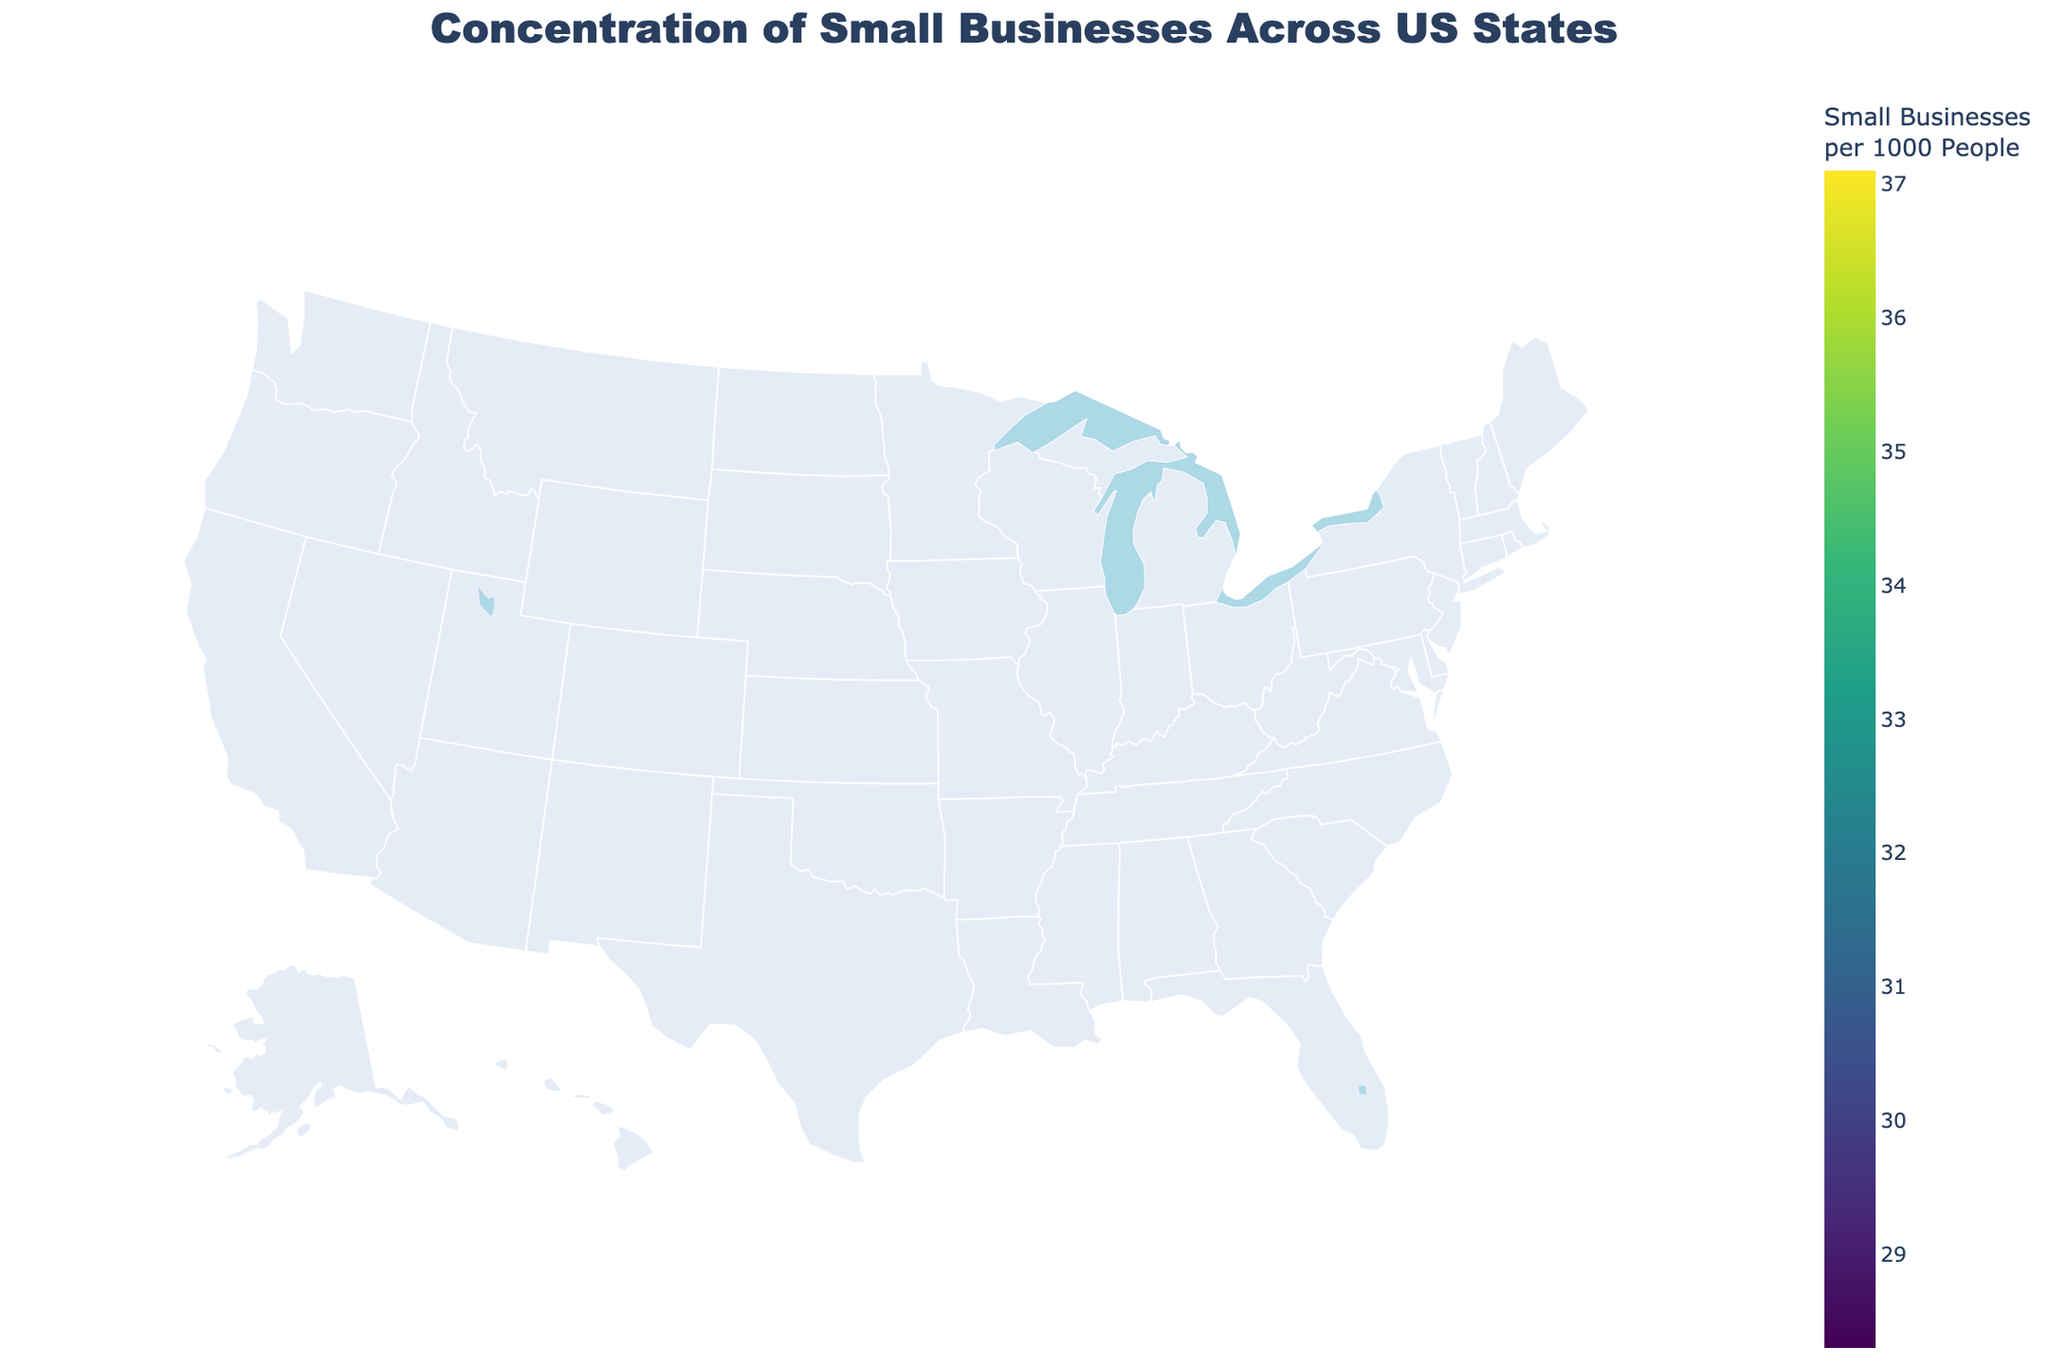Which state has the highest concentration of small businesses per 1000 people? From the figure, observe the state with the darkest shade, indicating the highest value on the color scale. The hover information will show that Florida has 37.1 small businesses per 1000 people.
Answer: Florida Which state has the lowest concentration of small businesses per 1000 people? From the figure, observe the state with the lightest shade, indicating the lowest value on the color scale. The hover information will show that Ohio has 28.3 small businesses per 1000 people.
Answer: Ohio How many states have a concentration of small businesses per 1000 people greater than 34? Refer to the color legend and identify states that fall into the darker color ranges. By checking the hover information for each state, count the states that have a value greater than 34. These states are California, Florida, New York, Washington, New Jersey, Massachusetts, Oregon, and Utah.
Answer: 8 What is the average concentration of small businesses per 1000 people for California and New York? From the figure, hover over California and New York to get their values (California: 35.2, New York: 34.9). Sum these values and divide by 2: (35.2 + 34.9) / 2 = 35.05.
Answer: 35.05 Which state has more small businesses per 1000 people, Texas or Georgia? From the figure, compare the values of Texas (32.8) and Georgia (33.6) by hovering over each state. Georgia has a higher value.
Answer: Georgia What is the range of the concentration of small businesses per 1000 people across the states? Find the maximum value from the hover information (Florida: 37.1) and the minimum value (Ohio: 28.3). Subtract the minimum from the maximum: 37.1 - 28.3 = 8.8.
Answer: 8.8 Which two states have the closest concentration of small businesses per 1000 people? By checking the values via hovering, compare the differences between neighboring values. The closest values are New York (34.9) and Massachusetts (34.8), with a difference of 0.1.
Answer: New York and Massachusetts What is the median concentration value of small businesses per 1000 people across all states? Order all values from smallest to largest and find the median, which is the middle value. The values in ascending order are:
28.3, 28.6, 28.7, 28.9, 29.4, 29.8, 30.1, 30.2, 30.5, 31.3, 31.5, 31.7, 31.9, 32.1, 32.2, 32.8, 32.8, 32.9, 33.1, 33.5, 33.6, 34.3, 34.6, 34.8, 34.9, 35.2, 35.7, 36.4, 36.8, 37.1. With 30 data points, the median will be the average of the 15th and 16th values: (32.2 + 32.8) / 2 = 32.5.
Answer: 32.5 Which region (East Coast, West Coast, Midwest, South) seems to have the highest concentration of small businesses per 1000 people? Analyze the regions based on the visual color intensity and hover information. Florida, New York, New Jersey, and Massachusetts (East Coast) show higher values on average compared to other regions.
Answer: East Coast 